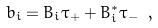Convert formula to latex. <formula><loc_0><loc_0><loc_500><loc_500>b _ { i } = B _ { i } \tau _ { + } + B _ { i } ^ { * } \tau _ { - } \ ,</formula> 